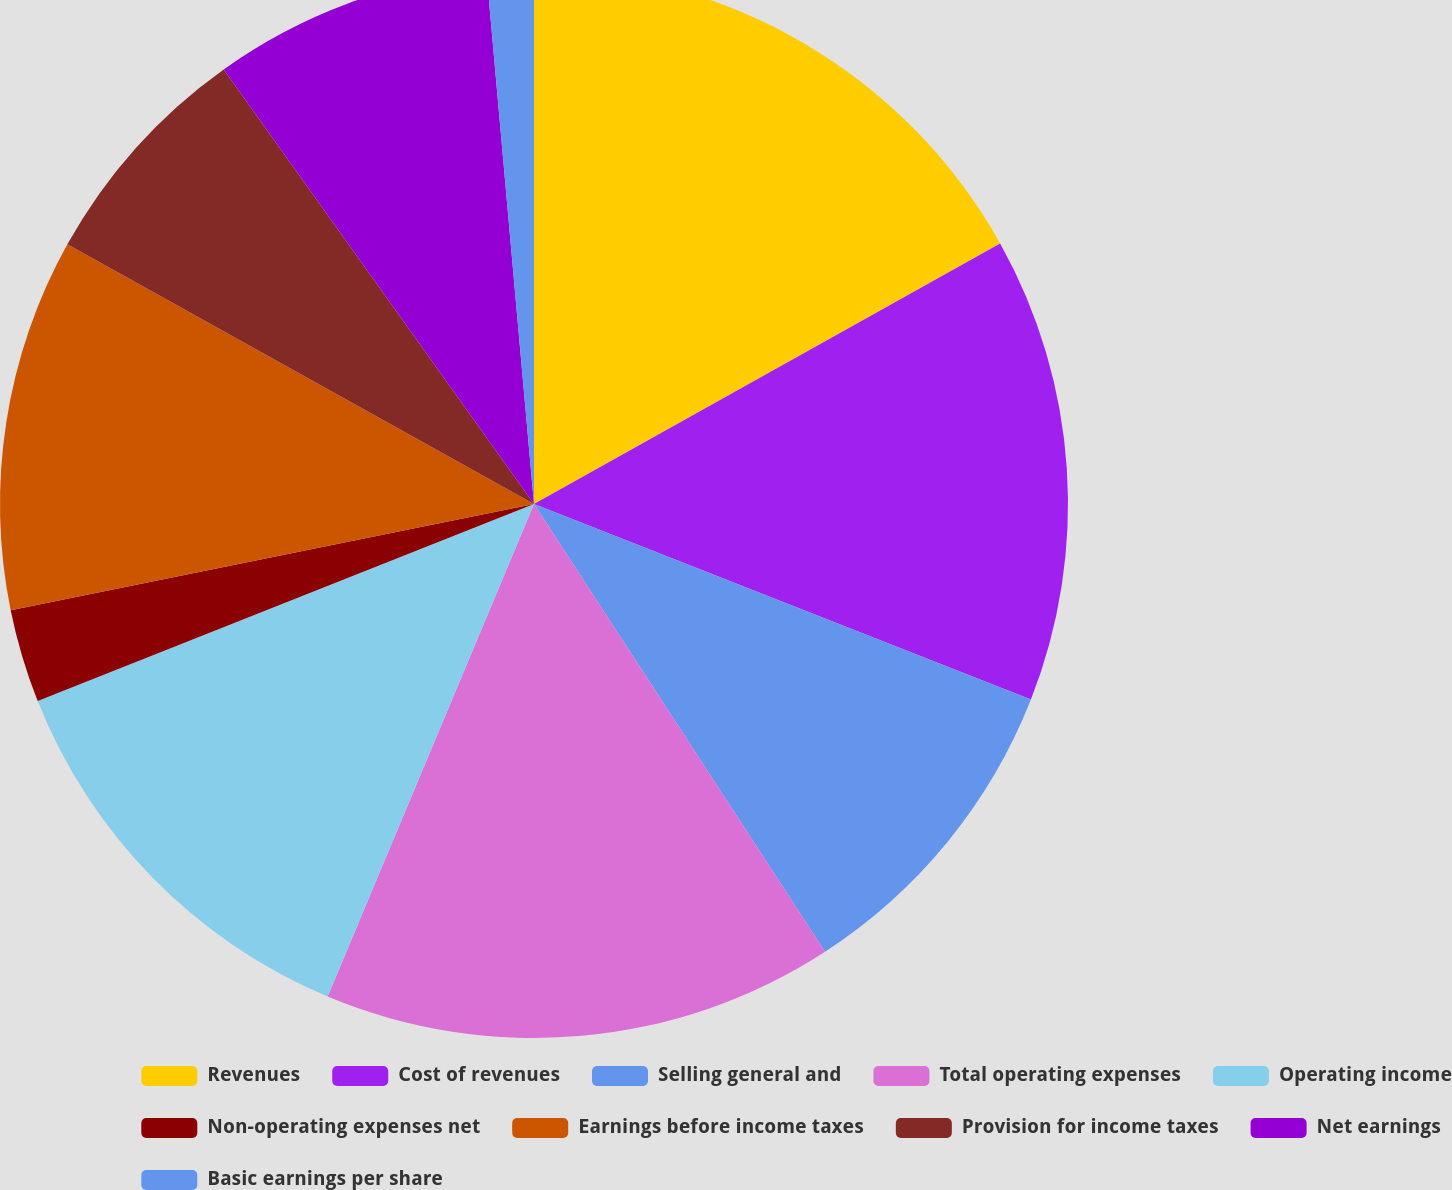Convert chart. <chart><loc_0><loc_0><loc_500><loc_500><pie_chart><fcel>Revenues<fcel>Cost of revenues<fcel>Selling general and<fcel>Total operating expenses<fcel>Operating income<fcel>Non-operating expenses net<fcel>Earnings before income taxes<fcel>Provision for income taxes<fcel>Net earnings<fcel>Basic earnings per share<nl><fcel>16.89%<fcel>14.08%<fcel>9.86%<fcel>15.49%<fcel>12.67%<fcel>2.83%<fcel>11.27%<fcel>7.05%<fcel>8.45%<fcel>1.42%<nl></chart> 